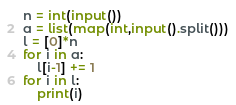<code> <loc_0><loc_0><loc_500><loc_500><_Python_>n = int(input())
a = list(map(int,input().split()))
l = [0]*n
for i in a:
    l[i-1] += 1
for i in l:
    print(i)</code> 